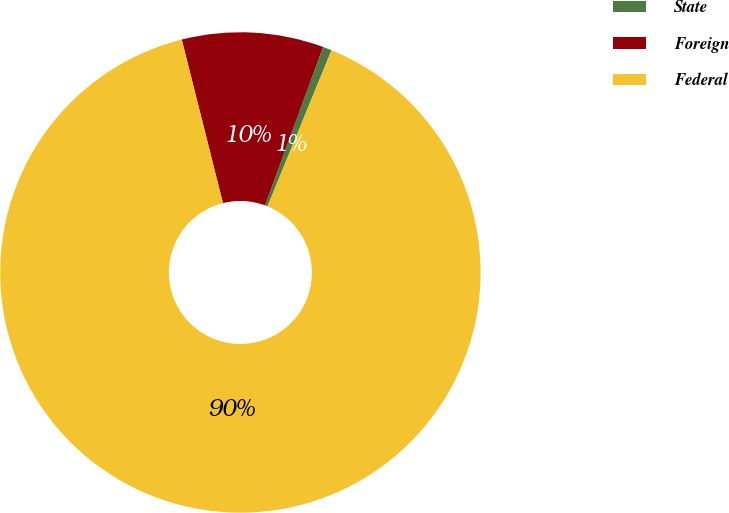<chart> <loc_0><loc_0><loc_500><loc_500><pie_chart><fcel>State<fcel>Foreign<fcel>Federal<nl><fcel>0.6%<fcel>9.52%<fcel>89.88%<nl></chart> 